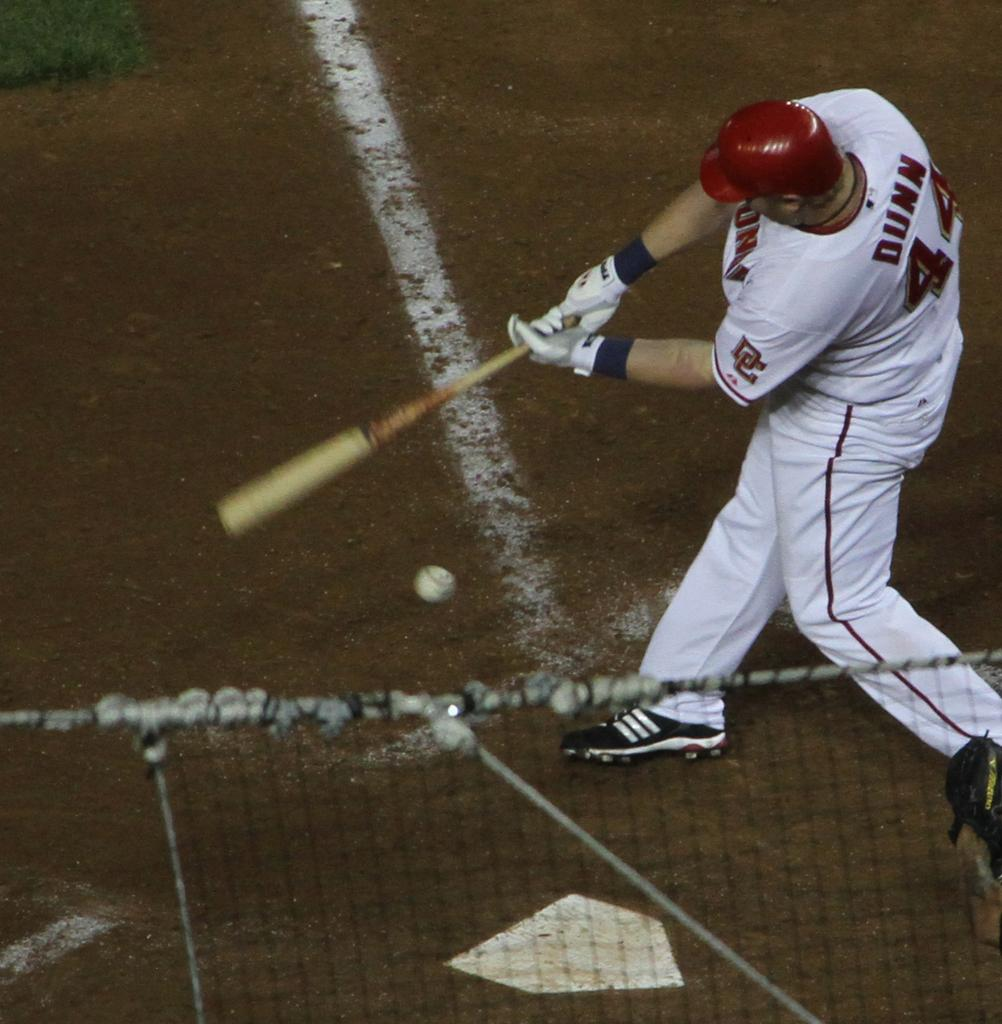Provide a one-sentence caption for the provided image. A man wearing number 44 swings his bat at the ball. 